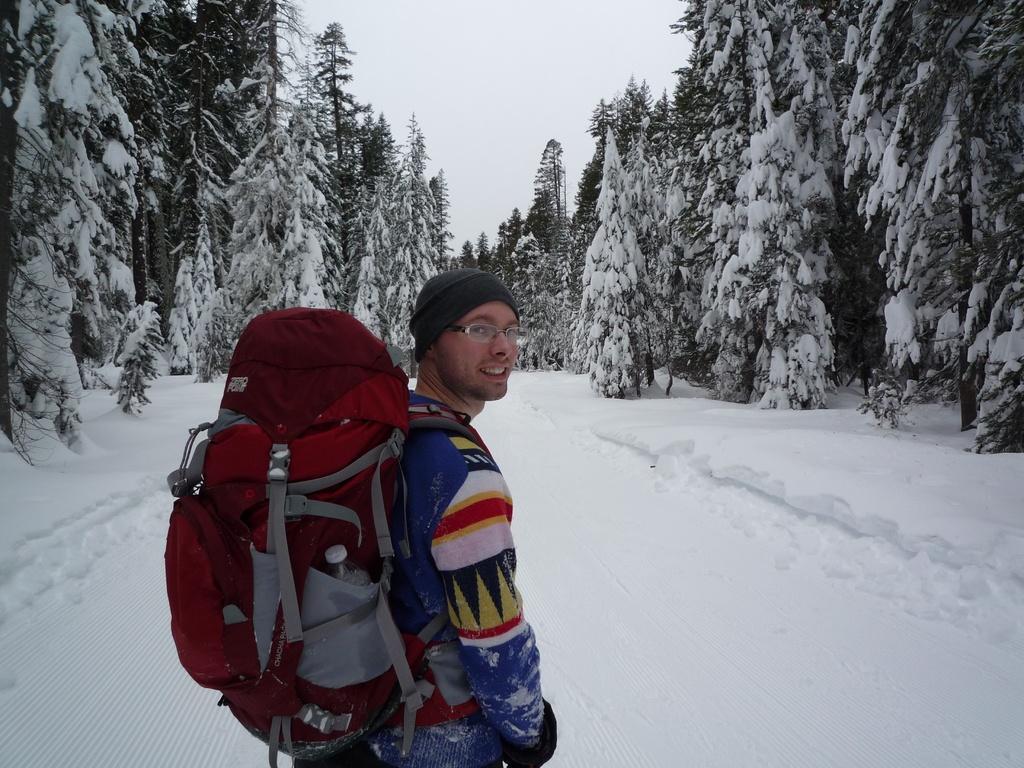Could you give a brief overview of what you see in this image? Here we can see a man standing with a back pack at a snowy area, and here at the left side and the right side both we can see trees covered with snow, the sky is clear 